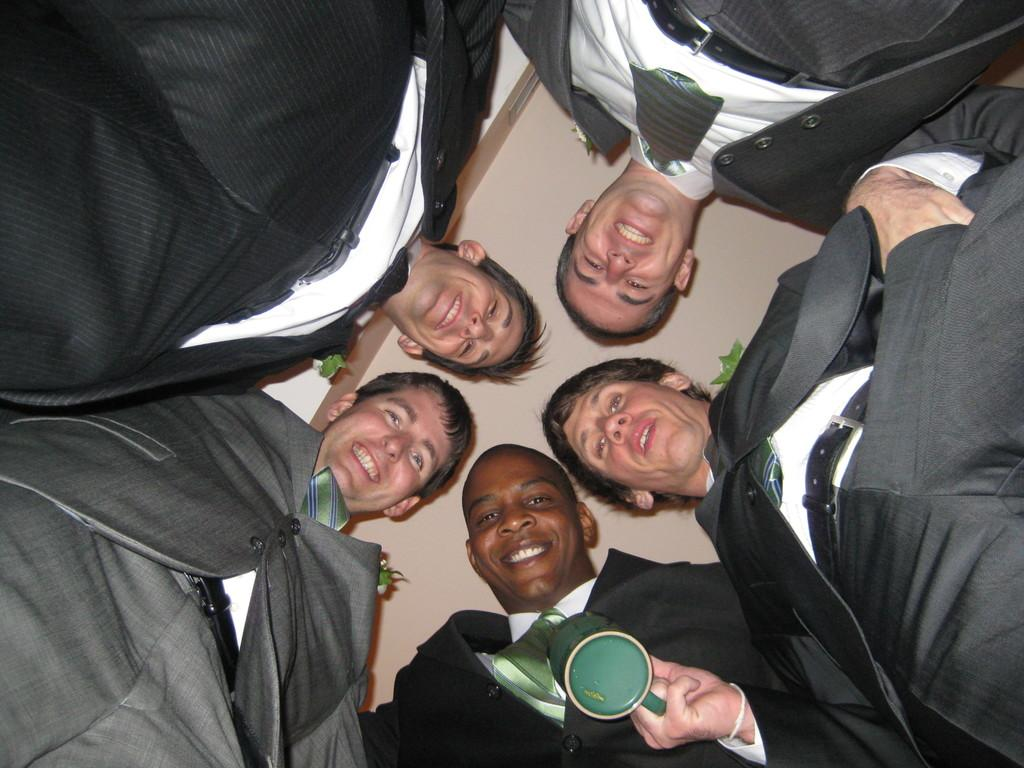What is the main subject of the image? The main subject of the image is a group of men. What are the men wearing in the image? The men are wearing suits in the image. What object can be seen in the middle of the image? There is a cup in the middle of the image. What is visible at the top of the image? There is a ceiling visible at the top of the image. What type of glove is the man wearing on his left hand in the image? There is no glove visible on any of the men's hands in the image. What disease is the man in the center of the image suffering from? There is no indication of any disease or illness in the image. 